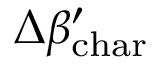<formula> <loc_0><loc_0><loc_500><loc_500>\Delta \beta _ { c h a r } ^ { \prime }</formula> 